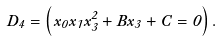<formula> <loc_0><loc_0><loc_500><loc_500>D _ { 4 } = \left ( x _ { 0 } x _ { 1 } x _ { 3 } ^ { 2 } + B x _ { 3 } + C = 0 \right ) .</formula> 